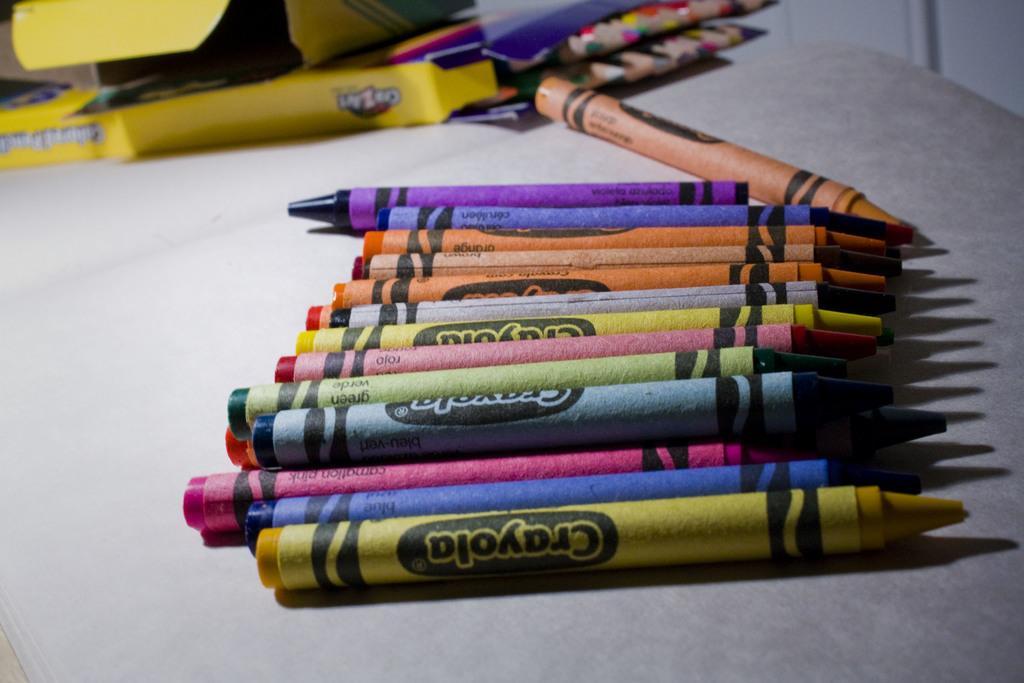Could you give a brief overview of what you see in this image? In this image I can see crayons and boxes on a table. This image is taken may be in a room. 